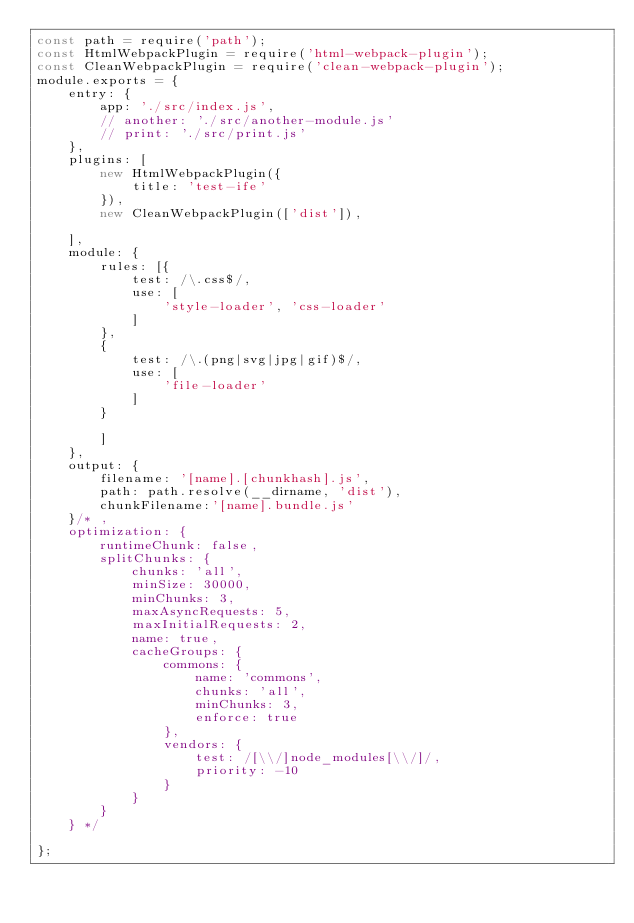Convert code to text. <code><loc_0><loc_0><loc_500><loc_500><_JavaScript_>const path = require('path');
const HtmlWebpackPlugin = require('html-webpack-plugin');
const CleanWebpackPlugin = require('clean-webpack-plugin');
module.exports = {
    entry: {
        app: './src/index.js',
        // another: './src/another-module.js'
        // print: './src/print.js'
    },
    plugins: [
        new HtmlWebpackPlugin({
            title: 'test-ife'
        }),
        new CleanWebpackPlugin(['dist']),
        
    ],
    module: {
        rules: [{
            test: /\.css$/,
            use: [
                'style-loader', 'css-loader'
            ]
        },
        {
            test: /\.(png|svg|jpg|gif)$/,
            use: [
                'file-loader'
            ]
        }

        ]
    },
    output: {
        filename: '[name].[chunkhash].js',
        path: path.resolve(__dirname, 'dist'),
        chunkFilename:'[name].bundle.js'
    }/* ,
    optimization: {
        runtimeChunk: false,
        splitChunks: {
            chunks: 'all',
            minSize: 30000,
            minChunks: 3,
            maxAsyncRequests: 5,
            maxInitialRequests: 2,
            name: true,
            cacheGroups: {
                commons: {
                    name: 'commons',
                    chunks: 'all',
                    minChunks: 3,
                    enforce: true
                },
                vendors: {
                    test: /[\\/]node_modules[\\/]/,
                    priority: -10
                }
            }
        }
    } */

};</code> 